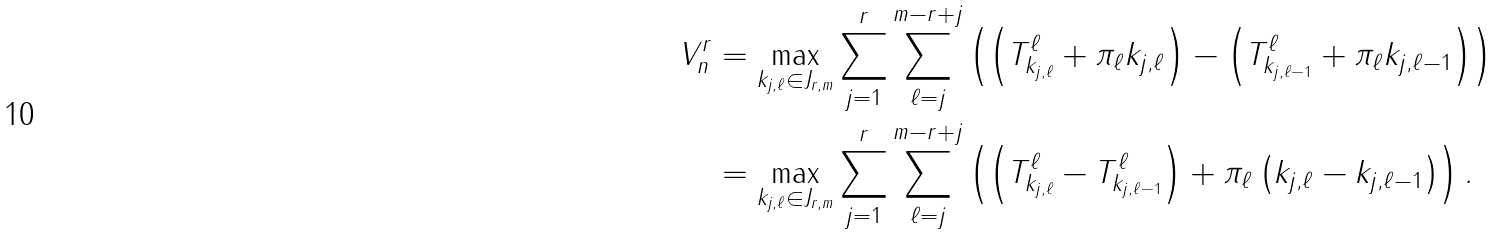<formula> <loc_0><loc_0><loc_500><loc_500>V ^ { r } _ { n } & = \max _ { k _ { j , \ell } \in J _ { r , m } } \sum _ { j = 1 } ^ { r } \sum _ { \ell = j } ^ { m - r + j } \left ( \left ( T ^ { \ell } _ { k _ { j , \ell } } + \pi _ { \ell } k _ { j , \ell } \right ) - \left ( T ^ { \ell } _ { k _ { j , \ell - 1 } } + \pi _ { \ell } k _ { j , \ell - 1 } \right ) \right ) \\ & = \max _ { k _ { j , \ell } \in J _ { r , m } } \sum _ { j = 1 } ^ { r } \sum _ { \ell = j } ^ { m - r + j } \left ( \left ( T ^ { \ell } _ { k _ { j , \ell } } - T ^ { \ell } _ { k _ { j , \ell - 1 } } \right ) + \pi _ { \ell } \left ( k _ { j , \ell } - k _ { j , \ell - 1 } \right ) \right ) .</formula> 